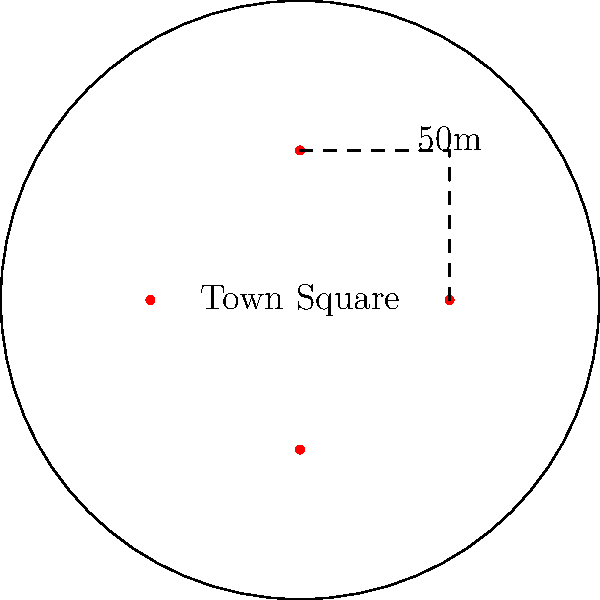As a local organizer of a traditional festival, you're planning an event in the town square. The square is circular with a diameter of 50 meters. Assuming each person needs about 0.5 square meters of space, estimate how many people can comfortably fit in the square for the cultural celebration. Round your answer to the nearest hundred. To solve this problem, let's follow these steps:

1. Calculate the area of the circular town square:
   The formula for the area of a circle is $A = \pi r^2$, where $r$ is the radius.
   Diameter = 50 m, so radius = 25 m
   $A = \pi (25\text{ m})^2 = 625\pi \text{ m}^2$

2. Convert this to square meters:
   $A \approx 1963.5 \text{ m}^2$

3. Calculate the number of people that can fit:
   Each person needs 0.5 square meters
   Number of people = Total area / Area per person
   $N = 1963.5 \text{ m}^2 / 0.5 \text{ m}^2/\text{person} = 3927 \text{ people}$

4. Round to the nearest hundred:
   3927 rounds to 3900 people

Therefore, approximately 3900 people can comfortably fit in the town square for the cultural event.
Answer: 3900 people 